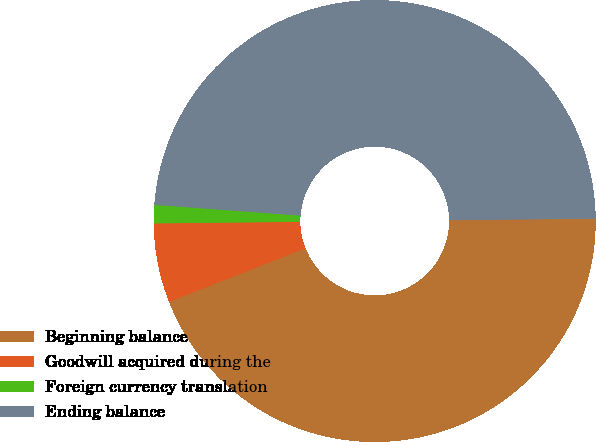Convert chart to OTSL. <chart><loc_0><loc_0><loc_500><loc_500><pie_chart><fcel>Beginning balance<fcel>Goodwill acquired during the<fcel>Foreign currency translation<fcel>Ending balance<nl><fcel>44.21%<fcel>5.79%<fcel>1.34%<fcel>48.66%<nl></chart> 